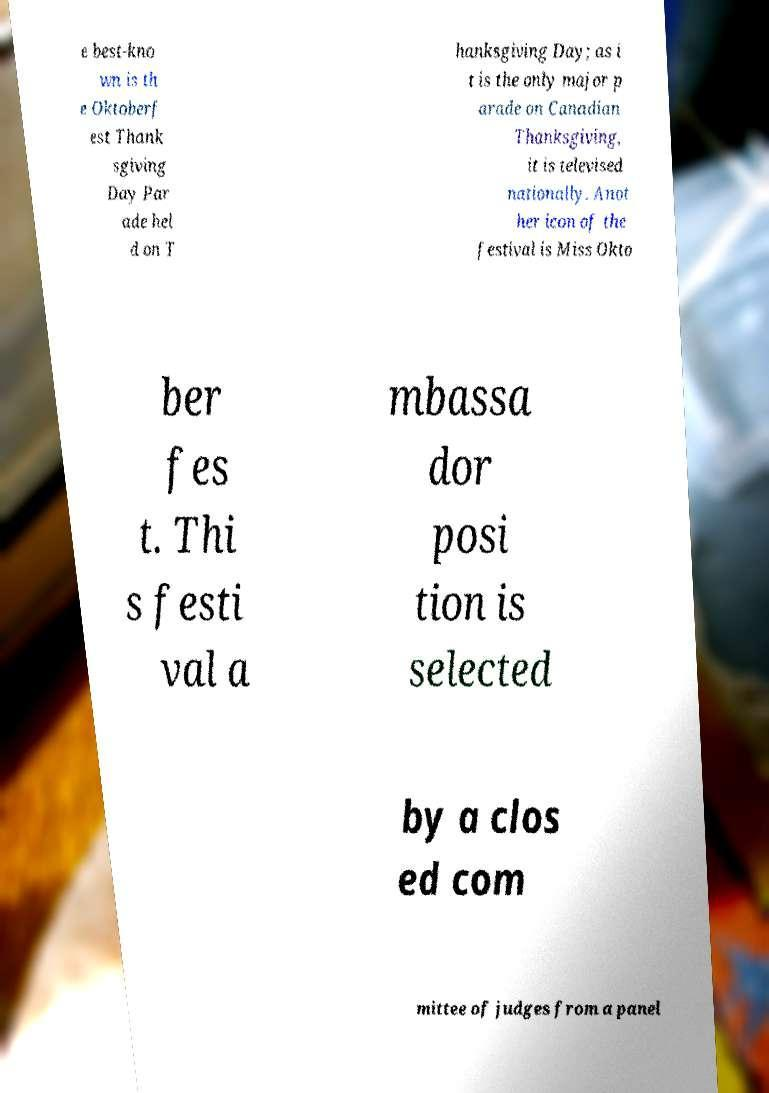Please read and relay the text visible in this image. What does it say? e best-kno wn is th e Oktoberf est Thank sgiving Day Par ade hel d on T hanksgiving Day; as i t is the only major p arade on Canadian Thanksgiving, it is televised nationally. Anot her icon of the festival is Miss Okto ber fes t. Thi s festi val a mbassa dor posi tion is selected by a clos ed com mittee of judges from a panel 